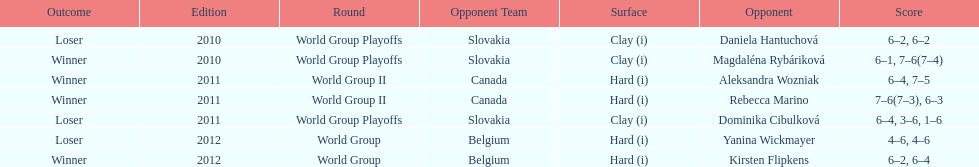What was the next game listed after the world group ii rounds? World Group Playoffs. 